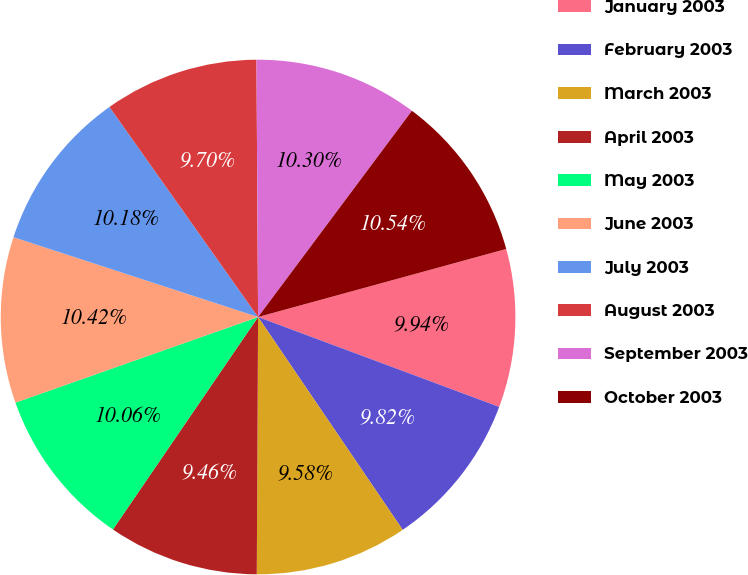Convert chart to OTSL. <chart><loc_0><loc_0><loc_500><loc_500><pie_chart><fcel>January 2003<fcel>February 2003<fcel>March 2003<fcel>April 2003<fcel>May 2003<fcel>June 2003<fcel>July 2003<fcel>August 2003<fcel>September 2003<fcel>October 2003<nl><fcel>9.94%<fcel>9.82%<fcel>9.58%<fcel>9.46%<fcel>10.06%<fcel>10.42%<fcel>10.18%<fcel>9.7%<fcel>10.3%<fcel>10.54%<nl></chart> 